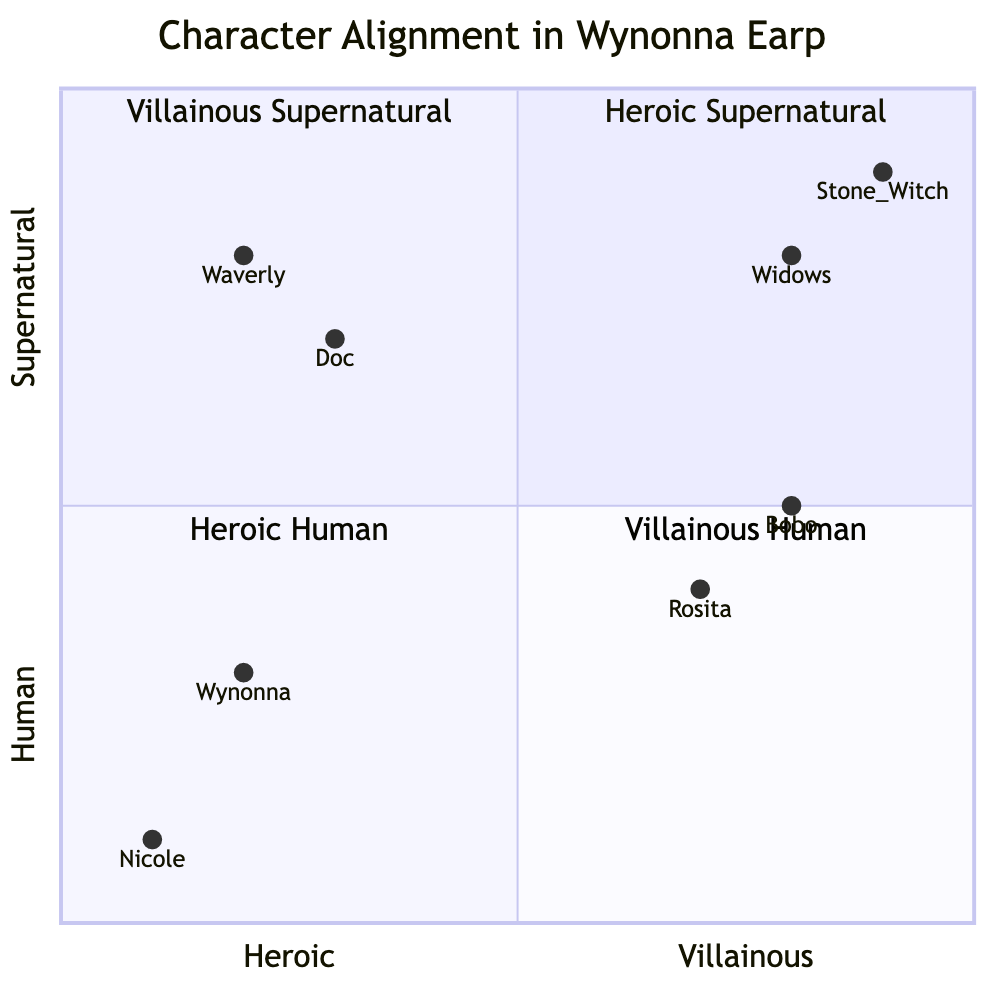What characters are in the Heroic Supernatural quadrant? The Heroic Supernatural quadrant contains the characters Doc Holliday and Waverly Earp. These characters are located in the upper left section of the quadrant chart, indicating their heroic nature and supernatural attributes.
Answer: Doc Holliday, Waverly Earp Who is the most villainous character according to this chart? The character that is positioned the furthest towards the villainous end of the x-axis is the Stone Witch, indicating her role as a significant threat with villainous traits. This character is plotted close to the maximum value on the villainous side, showing her distinct alignment.
Answer: Stone Witch How many characters are in the Villainous Human quadrant? The Villainous Human quadrant has two characters: Bobo Del Rey and Rosita Bustillos. This is observed in the lower right section of the quadrant representing villainy among humans.
Answer: 2 Which character is the least heroic based on this diagram? The character with the lowest heroic value on the x-axis is Bobo Del Rey, positioned at the far end of the Villainous Human quadrant. This indicates that he has more villainous traits than heroic ones according to his placement on the chart.
Answer: Bobo Del Rey Is there any character in both the Human and Supernatural categories? No, each category has characters that are distinctly either human or supernatural. For example, the Heroic category only includes human characters in one quadrant and supernatural characters in another, thus there is no overlap.
Answer: No Which character falls into the Heroic Human quadrant? The characters located in the Heroic Human quadrant are Wynonna Earp and Nicole Haught. These characters are portrayed as heroic figures defending their town and are classified as human.
Answer: Wynonna Earp, Nicole Haught What is the x-coordinate of Waverly Earp? Waverly Earp is plotted at an x-coordinate of 0.2 on the quadrant chart, reflecting her alignment as more heroic than villainous, though she possesses supernatural abilities.
Answer: 0.2 Which character has a higher villainous alignment, Rosita or Doc Holliday? Comparing their positions, Rosita has a villainous alignment value of 0.7, while Doc Holliday's villainous alignment is only 0.3. Therefore, Rosita represents a higher level of villainous traits than Doc Holliday.
Answer: Rosita 